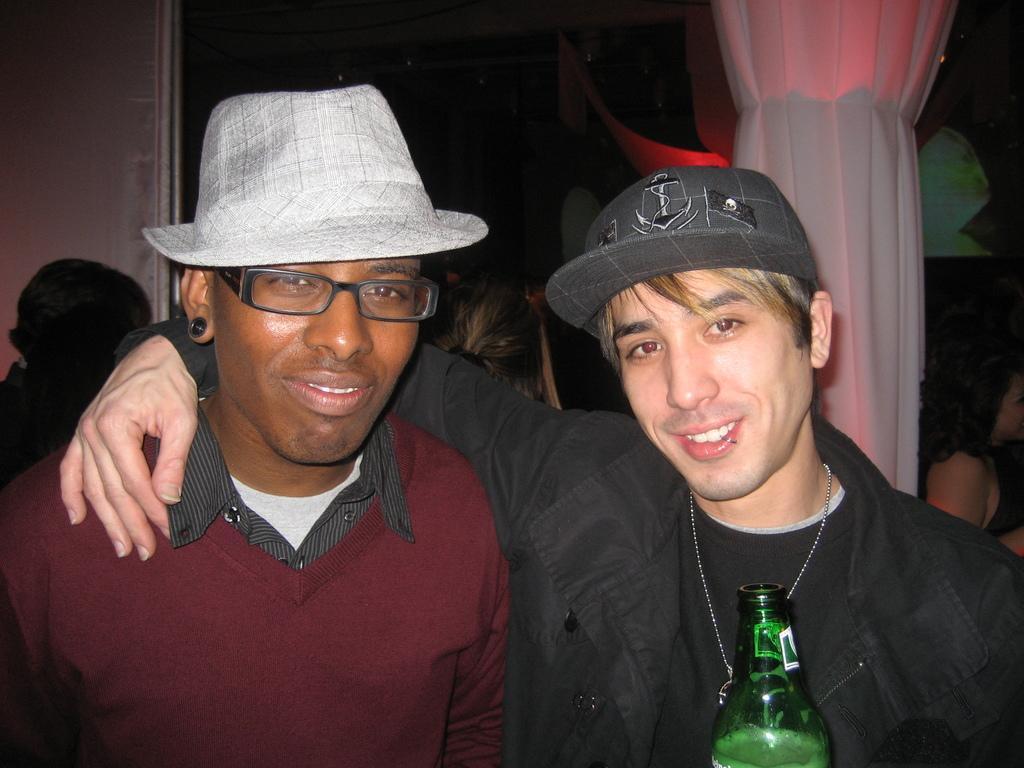How would you summarize this image in a sentence or two? This Picture describe a inside view of the room in which two boys are standing and giving the pose in the camera, On the right side we can see the a boy wearing black jacket and cap on the head, Holding the green bottle in this hand and smiling in the camera, Beside him another boy wearing red sweatshirt and a cow boy cap is smiling in the camera. Behind we can see the a woman standing, white curtain and a glass window. 